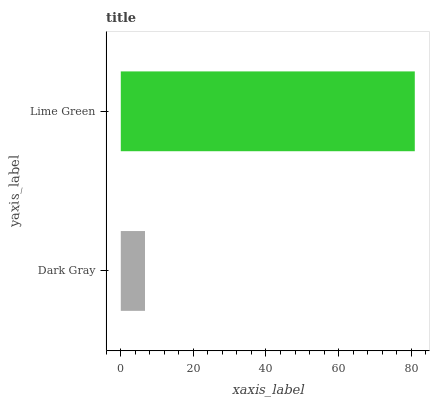Is Dark Gray the minimum?
Answer yes or no. Yes. Is Lime Green the maximum?
Answer yes or no. Yes. Is Lime Green the minimum?
Answer yes or no. No. Is Lime Green greater than Dark Gray?
Answer yes or no. Yes. Is Dark Gray less than Lime Green?
Answer yes or no. Yes. Is Dark Gray greater than Lime Green?
Answer yes or no. No. Is Lime Green less than Dark Gray?
Answer yes or no. No. Is Lime Green the high median?
Answer yes or no. Yes. Is Dark Gray the low median?
Answer yes or no. Yes. Is Dark Gray the high median?
Answer yes or no. No. Is Lime Green the low median?
Answer yes or no. No. 